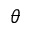Convert formula to latex. <formula><loc_0><loc_0><loc_500><loc_500>\theta</formula> 